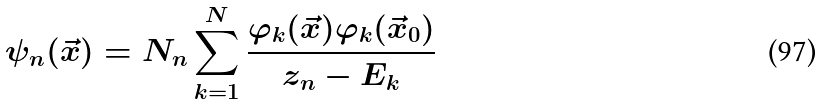<formula> <loc_0><loc_0><loc_500><loc_500>\psi _ { n } ( \vec { x } ) = N _ { n } \sum _ { k = 1 } ^ { N } \frac { \varphi _ { k } ( \vec { x } ) \varphi _ { k } ( \vec { x } _ { 0 } ) } { z _ { n } - E _ { k } }</formula> 